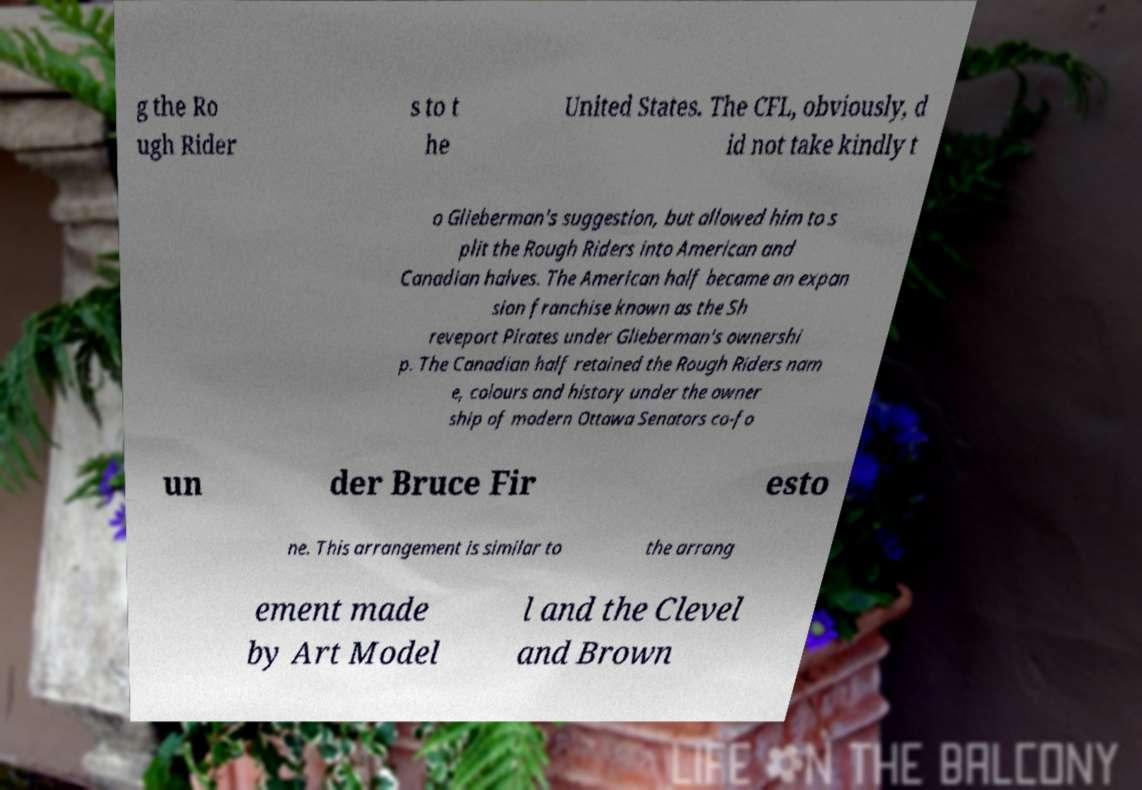What messages or text are displayed in this image? I need them in a readable, typed format. g the Ro ugh Rider s to t he United States. The CFL, obviously, d id not take kindly t o Glieberman's suggestion, but allowed him to s plit the Rough Riders into American and Canadian halves. The American half became an expan sion franchise known as the Sh reveport Pirates under Glieberman's ownershi p. The Canadian half retained the Rough Riders nam e, colours and history under the owner ship of modern Ottawa Senators co-fo un der Bruce Fir esto ne. This arrangement is similar to the arrang ement made by Art Model l and the Clevel and Brown 